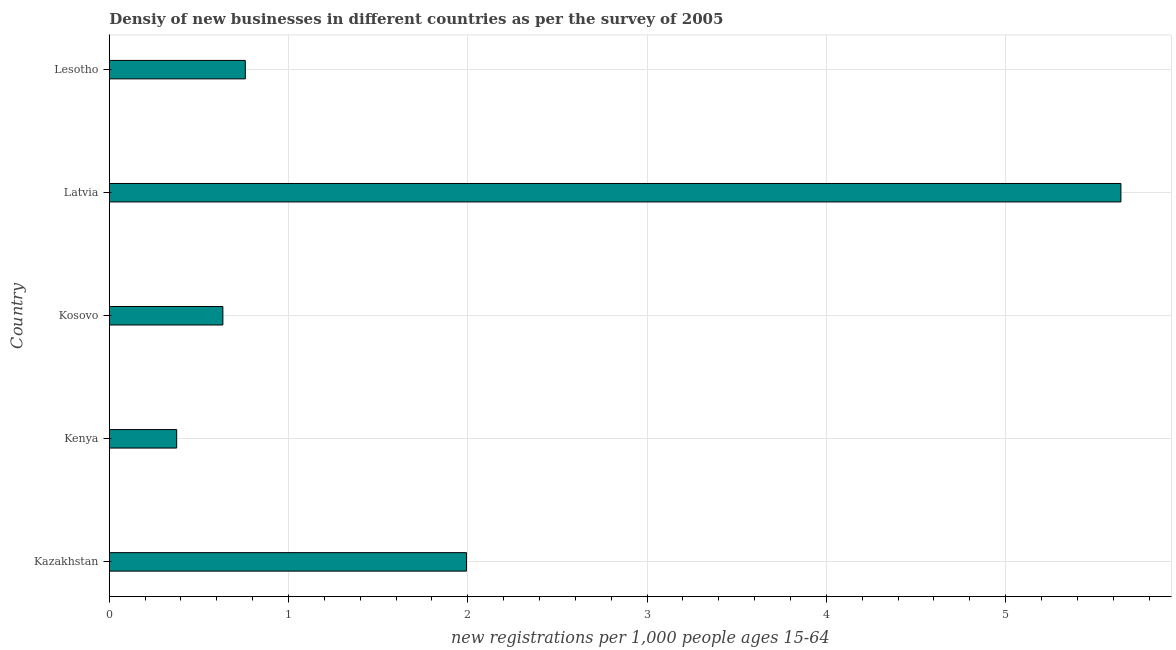Does the graph contain grids?
Offer a terse response. Yes. What is the title of the graph?
Give a very brief answer. Densiy of new businesses in different countries as per the survey of 2005. What is the label or title of the X-axis?
Your response must be concise. New registrations per 1,0 people ages 15-64. What is the density of new business in Lesotho?
Provide a short and direct response. 0.76. Across all countries, what is the maximum density of new business?
Offer a very short reply. 5.64. Across all countries, what is the minimum density of new business?
Provide a succinct answer. 0.38. In which country was the density of new business maximum?
Keep it short and to the point. Latvia. In which country was the density of new business minimum?
Provide a short and direct response. Kenya. What is the sum of the density of new business?
Provide a short and direct response. 9.4. What is the difference between the density of new business in Kenya and Kosovo?
Your answer should be very brief. -0.26. What is the average density of new business per country?
Ensure brevity in your answer.  1.88. What is the median density of new business?
Your answer should be compact. 0.76. What is the ratio of the density of new business in Latvia to that in Lesotho?
Provide a short and direct response. 7.44. Is the density of new business in Kazakhstan less than that in Latvia?
Offer a very short reply. Yes. What is the difference between the highest and the second highest density of new business?
Your answer should be very brief. 3.65. Is the sum of the density of new business in Kosovo and Latvia greater than the maximum density of new business across all countries?
Provide a succinct answer. Yes. What is the difference between the highest and the lowest density of new business?
Keep it short and to the point. 5.27. In how many countries, is the density of new business greater than the average density of new business taken over all countries?
Offer a terse response. 2. How many bars are there?
Your answer should be compact. 5. Are all the bars in the graph horizontal?
Keep it short and to the point. Yes. How many countries are there in the graph?
Offer a terse response. 5. Are the values on the major ticks of X-axis written in scientific E-notation?
Ensure brevity in your answer.  No. What is the new registrations per 1,000 people ages 15-64 in Kazakhstan?
Give a very brief answer. 1.99. What is the new registrations per 1,000 people ages 15-64 of Kenya?
Provide a short and direct response. 0.38. What is the new registrations per 1,000 people ages 15-64 in Kosovo?
Your response must be concise. 0.63. What is the new registrations per 1,000 people ages 15-64 of Latvia?
Your response must be concise. 5.64. What is the new registrations per 1,000 people ages 15-64 of Lesotho?
Offer a terse response. 0.76. What is the difference between the new registrations per 1,000 people ages 15-64 in Kazakhstan and Kenya?
Ensure brevity in your answer.  1.62. What is the difference between the new registrations per 1,000 people ages 15-64 in Kazakhstan and Kosovo?
Your answer should be compact. 1.36. What is the difference between the new registrations per 1,000 people ages 15-64 in Kazakhstan and Latvia?
Make the answer very short. -3.65. What is the difference between the new registrations per 1,000 people ages 15-64 in Kazakhstan and Lesotho?
Your answer should be compact. 1.23. What is the difference between the new registrations per 1,000 people ages 15-64 in Kenya and Kosovo?
Keep it short and to the point. -0.26. What is the difference between the new registrations per 1,000 people ages 15-64 in Kenya and Latvia?
Offer a terse response. -5.27. What is the difference between the new registrations per 1,000 people ages 15-64 in Kenya and Lesotho?
Provide a short and direct response. -0.38. What is the difference between the new registrations per 1,000 people ages 15-64 in Kosovo and Latvia?
Provide a short and direct response. -5.01. What is the difference between the new registrations per 1,000 people ages 15-64 in Kosovo and Lesotho?
Offer a terse response. -0.13. What is the difference between the new registrations per 1,000 people ages 15-64 in Latvia and Lesotho?
Provide a short and direct response. 4.88. What is the ratio of the new registrations per 1,000 people ages 15-64 in Kazakhstan to that in Kosovo?
Give a very brief answer. 3.14. What is the ratio of the new registrations per 1,000 people ages 15-64 in Kazakhstan to that in Latvia?
Give a very brief answer. 0.35. What is the ratio of the new registrations per 1,000 people ages 15-64 in Kazakhstan to that in Lesotho?
Provide a succinct answer. 2.63. What is the ratio of the new registrations per 1,000 people ages 15-64 in Kenya to that in Kosovo?
Offer a terse response. 0.59. What is the ratio of the new registrations per 1,000 people ages 15-64 in Kenya to that in Latvia?
Your answer should be very brief. 0.07. What is the ratio of the new registrations per 1,000 people ages 15-64 in Kenya to that in Lesotho?
Ensure brevity in your answer.  0.49. What is the ratio of the new registrations per 1,000 people ages 15-64 in Kosovo to that in Latvia?
Your answer should be compact. 0.11. What is the ratio of the new registrations per 1,000 people ages 15-64 in Kosovo to that in Lesotho?
Offer a terse response. 0.83. What is the ratio of the new registrations per 1,000 people ages 15-64 in Latvia to that in Lesotho?
Provide a short and direct response. 7.44. 